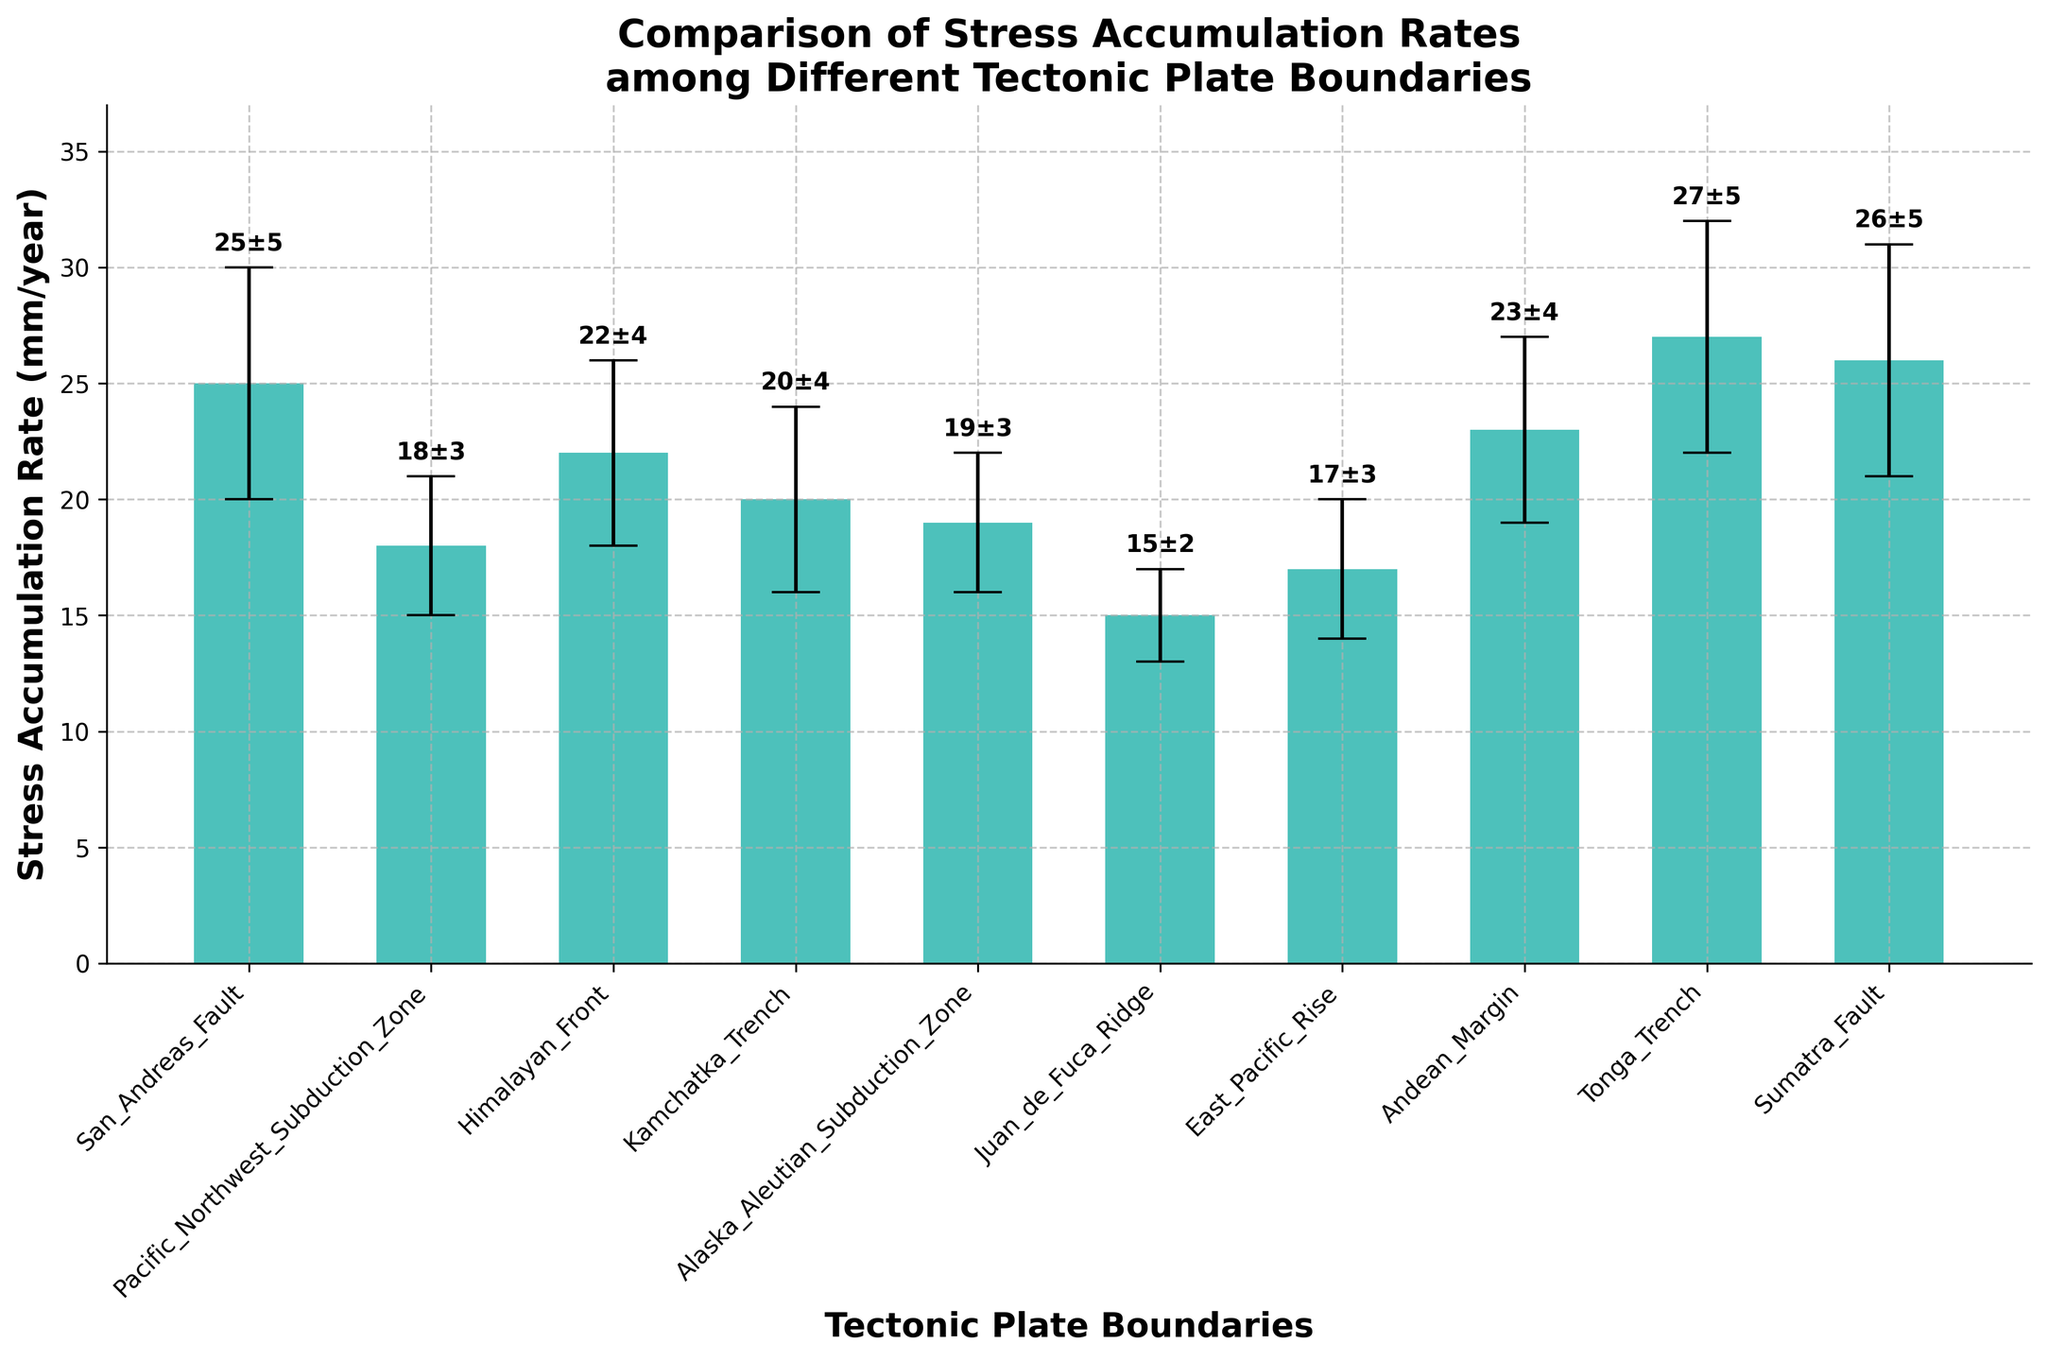What is the title of the figure? The title is typically found at the top of the figure and summarizes the content of the plot.
Answer: Comparison of Stress Accumulation Rates among Different Tectonic Plate Boundaries Which tectonic plate boundary has the highest stress accumulation rate? Find the bar with the highest numerical value; this corresponds to the plate boundary with the highest stress accumulation rate.
Answer: Tonga Trench Which tectonic plate boundary has the lowest stress accumulation rate? Look for the bar with the smallest numerical value; this indicates the plate boundary with the lowest stress accumulation rate.
Answer: Juan de Fuca Ridge What is the error range for the San Andreas Fault? The error range is given by the length of the error bars above and below the bar for San Andreas Fault.
Answer: ±5 mm/year What is the difference in stress accumulation rates between the San Andreas Fault and the Juan de Fuca Ridge? Subtract the stress accumulation rate of the Juan de Fuca Ridge from that of the San Andreas Fault.
Answer: 25 - 15 = 10 mm/year How many tectonic plate boundaries are compared in the figure? Count the number of bars; each bar represents a different tectonic plate boundary.
Answer: 10 Which two tectonic plate boundaries have the same error margin of ±3 mm/year? Identify the boundaries with identical error bars of ±3 mm/year.
Answer: Pacific Northwest Subduction Zone and Alaska Aleutian Subduction Zone What is the median stress accumulation rate among all the tectonic plate boundaries? Arrange all the stress accumulation rates in numerical order and find the middle value. If there's an even number of values, calculate the average of the two middle numbers. Rates: [15, 17, 18, 19, 20, 22, 23, 25, 26, 27]. The middle values are 20 and 22. So the median is (20 + 22) / 2.
Answer: 21 mm/year Compare the error margins of the East Pacific Rise and the Andean Margin. Which one has a smaller error margin? Look at the lengths of the error bars for both boundaries; the one with the smaller length has the smaller error margin.
Answer: East Pacific Rise What is the range of stress accumulation rates (difference between the highest and lowest rates) shown in the figure? Subtract the smallest value from the largest value among the stress accumulation rates.
Answer: 27 - 15 = 12 mm/year Which tectonic plate boundaries have a stress accumulation rate above the average rate? Calculate the average stress accumulation rate, then identify the plate boundaries with rates above this average. Average = (25+18+22+20+19+15+17+23+27+26) / 10 = 21.2 mm/year. Plate boundaries with rates above 21.2 mm/year.
Answer: San Andreas Fault, Himalayan Front, Andean Margin, Tonga Trench, Sumatra Fault 